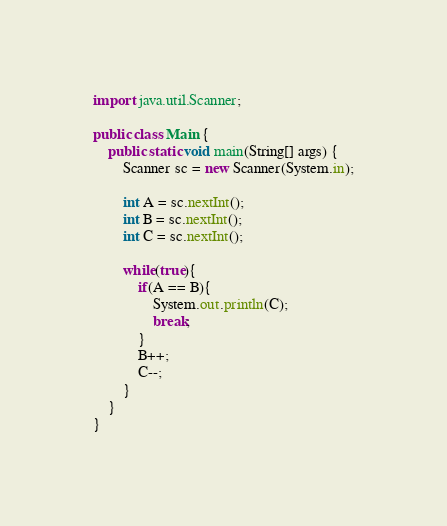<code> <loc_0><loc_0><loc_500><loc_500><_Java_>import java.util.Scanner;

public class Main {
	public static void main(String[] args) {
		Scanner sc = new Scanner(System.in);

		int A = sc.nextInt();
		int B = sc.nextInt();
		int C = sc.nextInt();
		
		while(true){
			if(A == B){
				System.out.println(C);
				break;
			}
			B++;
			C--;
		}
	}
}</code> 